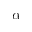<formula> <loc_0><loc_0><loc_500><loc_500>\alpha</formula> 